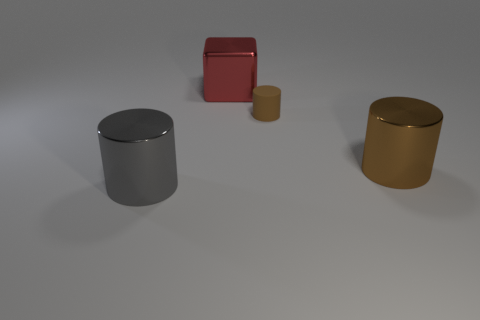Subtract all big shiny cylinders. How many cylinders are left? 1 Add 2 large metal spheres. How many objects exist? 6 Subtract all gray cylinders. How many cylinders are left? 2 Subtract all cubes. How many objects are left? 3 Subtract all gray spheres. How many brown cylinders are left? 2 Add 3 tiny brown matte cylinders. How many tiny brown matte cylinders exist? 4 Subtract 1 red blocks. How many objects are left? 3 Subtract 1 cylinders. How many cylinders are left? 2 Subtract all yellow blocks. Subtract all red balls. How many blocks are left? 1 Subtract all tiny blue objects. Subtract all brown things. How many objects are left? 2 